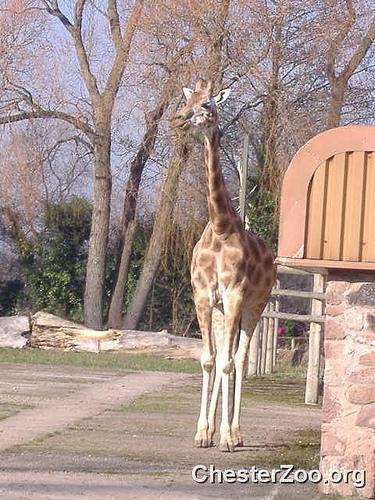How many giraffe are there?
Give a very brief answer. 1. 